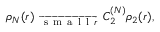<formula> <loc_0><loc_0><loc_500><loc_500>\begin{array} { r } { { \rho _ { N } ( r ) } _ { \ \overrightarrow { s m a l l r } \ } C _ { 2 } ^ { ( N ) } \rho _ { 2 } ( r ) , } \end{array}</formula> 